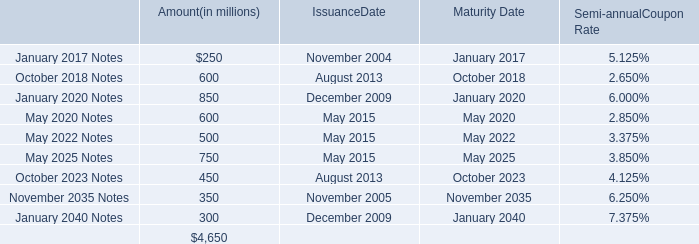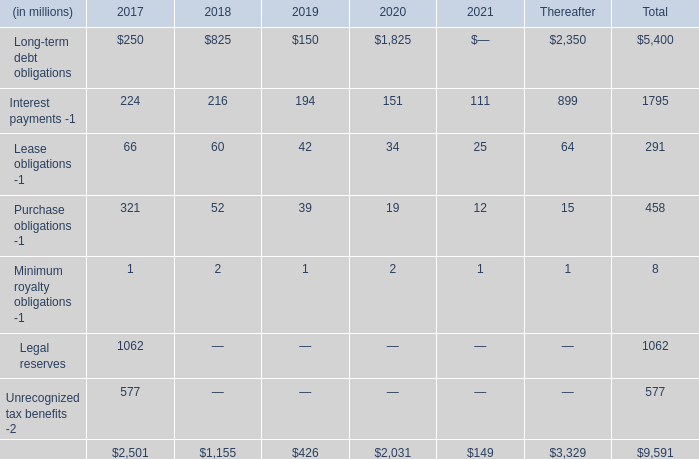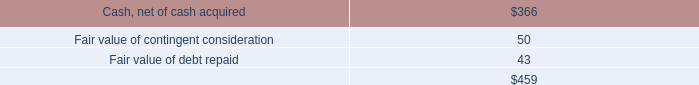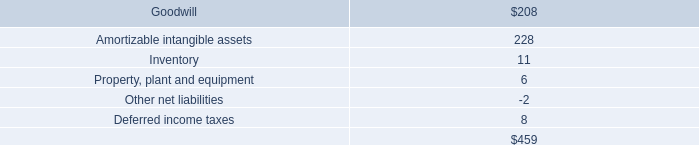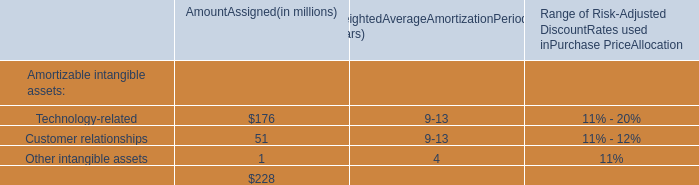what is the ratio of the insurance recovery to the incremental cost related to our closed bridgeton landfill 
Computations: (40.0 / 12.0)
Answer: 3.33333. 